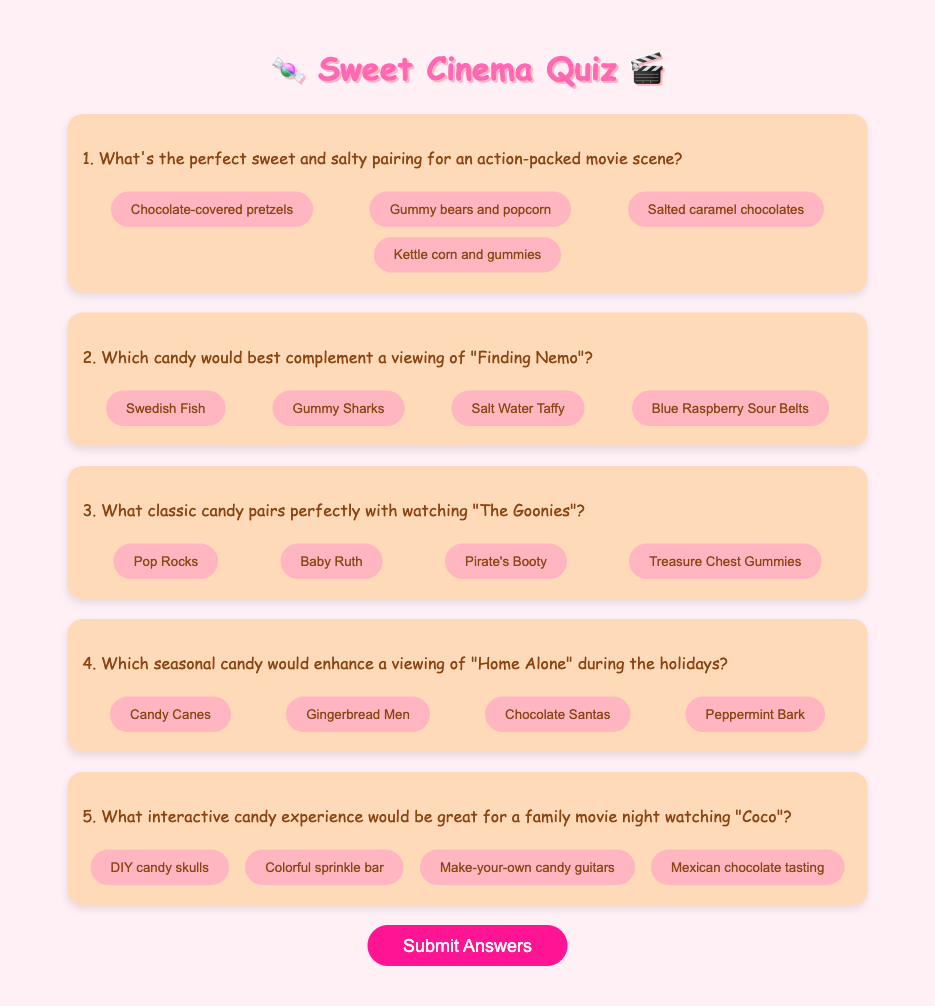What is the title of the quiz? The title of the quiz is prominently displayed at the top of the document.
Answer: Sweet Cinema Quiz How many questions are there in total? The document contains a total of five questions as can be counted in the quiz form.
Answer: 5 What color is the background of the document? The background color of the document is specified in the CSS styles section.
Answer: #FFF0F5 Which candy is suggested for the movie "Finding Nemo"? The second question lists options for candies, one of which is best for the movie "Finding Nemo."
Answer: Gummy Sharks What is the interactive candy experience suggested for "Coco"? The last question in the quiz lists options for candy experiences related to the movie "Coco."
Answer: DIY candy skulls What format are the quiz options provided in? The options for each question are presented as buttons, allowing users to interactively choose their answers.
Answer: Buttons 